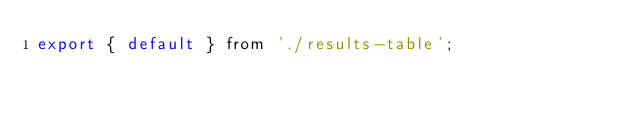Convert code to text. <code><loc_0><loc_0><loc_500><loc_500><_JavaScript_>export { default } from './results-table';
</code> 